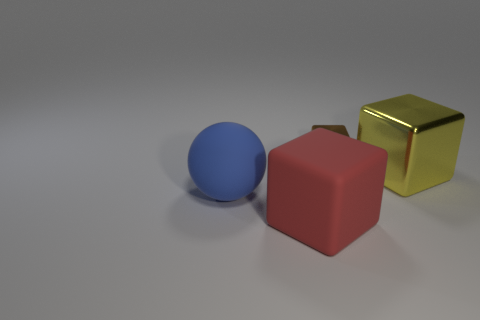How many brown shiny objects have the same shape as the red matte thing?
Provide a succinct answer. 1. What material is the red object that is the same shape as the large yellow thing?
Your answer should be very brief. Rubber. There is a thing that is on the left side of the yellow metallic thing and behind the large sphere; how big is it?
Your answer should be compact. Small. Is the number of blue spheres in front of the big shiny object greater than the number of yellow cubes that are behind the brown metallic block?
Offer a terse response. Yes. The big rubber thing that is the same shape as the big yellow metallic thing is what color?
Provide a short and direct response. Red. How many metallic objects are there?
Keep it short and to the point. 2. Do the big cube in front of the big yellow object and the blue object have the same material?
Ensure brevity in your answer.  Yes. How many small cubes are behind the brown block that is to the left of the big block that is right of the small block?
Offer a very short reply. 0. The brown metallic block is what size?
Your answer should be very brief. Small. What is the size of the cube behind the big yellow object?
Your response must be concise. Small. 